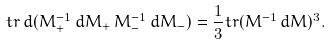<formula> <loc_0><loc_0><loc_500><loc_500>t r \, d ( M _ { + } ^ { - 1 } \, d M _ { + } \, M _ { - } ^ { - 1 } \, d M _ { - } ) = \frac { 1 } { 3 } t r ( M ^ { - 1 } \, d M ) ^ { 3 } .</formula> 